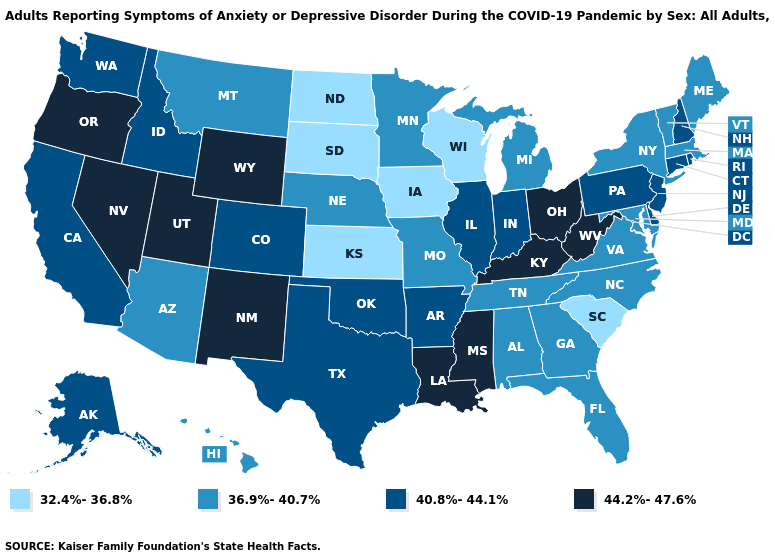Does Maine have the same value as Michigan?
Keep it brief. Yes. What is the value of Ohio?
Concise answer only. 44.2%-47.6%. Does Georgia have the same value as New York?
Answer briefly. Yes. Which states hav the highest value in the Northeast?
Be succinct. Connecticut, New Hampshire, New Jersey, Pennsylvania, Rhode Island. Name the states that have a value in the range 36.9%-40.7%?
Give a very brief answer. Alabama, Arizona, Florida, Georgia, Hawaii, Maine, Maryland, Massachusetts, Michigan, Minnesota, Missouri, Montana, Nebraska, New York, North Carolina, Tennessee, Vermont, Virginia. What is the value of New Mexico?
Quick response, please. 44.2%-47.6%. Name the states that have a value in the range 36.9%-40.7%?
Write a very short answer. Alabama, Arizona, Florida, Georgia, Hawaii, Maine, Maryland, Massachusetts, Michigan, Minnesota, Missouri, Montana, Nebraska, New York, North Carolina, Tennessee, Vermont, Virginia. What is the highest value in the West ?
Give a very brief answer. 44.2%-47.6%. Which states have the lowest value in the West?
Short answer required. Arizona, Hawaii, Montana. Does the first symbol in the legend represent the smallest category?
Answer briefly. Yes. Which states have the lowest value in the Northeast?
Give a very brief answer. Maine, Massachusetts, New York, Vermont. How many symbols are there in the legend?
Write a very short answer. 4. Name the states that have a value in the range 44.2%-47.6%?
Give a very brief answer. Kentucky, Louisiana, Mississippi, Nevada, New Mexico, Ohio, Oregon, Utah, West Virginia, Wyoming. Is the legend a continuous bar?
Be succinct. No. 